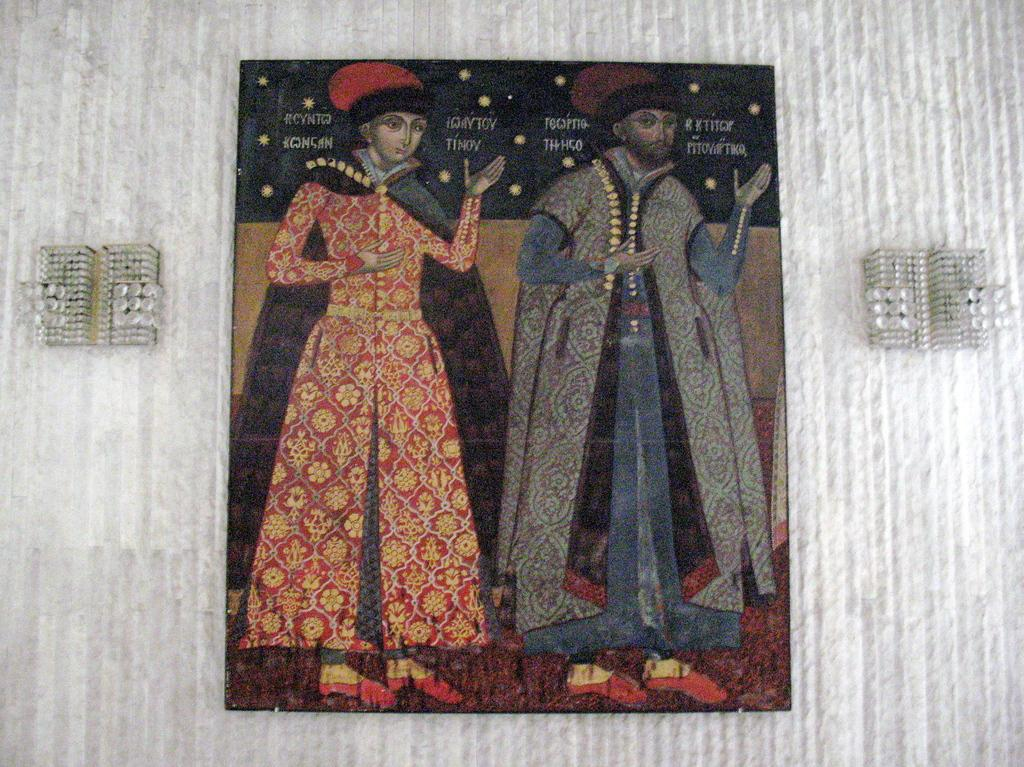What is present on the wall in the image? There is a poster in the image. Who or what is shown on the poster? There are two persons depicted on the poster. What can be seen on either side of the poster? There are two objects on either side of the poster. What type of skirt is the bulb wearing in the image? There is no bulb or skirt present in the image. How many masses can be seen in the image? There are no masses visible in the image. 